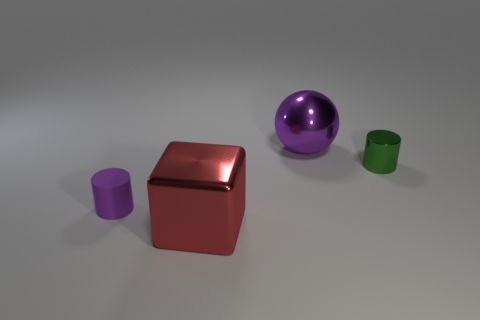Add 3 small green cylinders. How many objects exist? 7 Subtract all cubes. How many objects are left? 3 Add 3 large yellow shiny objects. How many large yellow shiny objects exist? 3 Subtract 0 yellow balls. How many objects are left? 4 Subtract all green things. Subtract all big red objects. How many objects are left? 2 Add 4 tiny green metal objects. How many tiny green metal objects are left? 5 